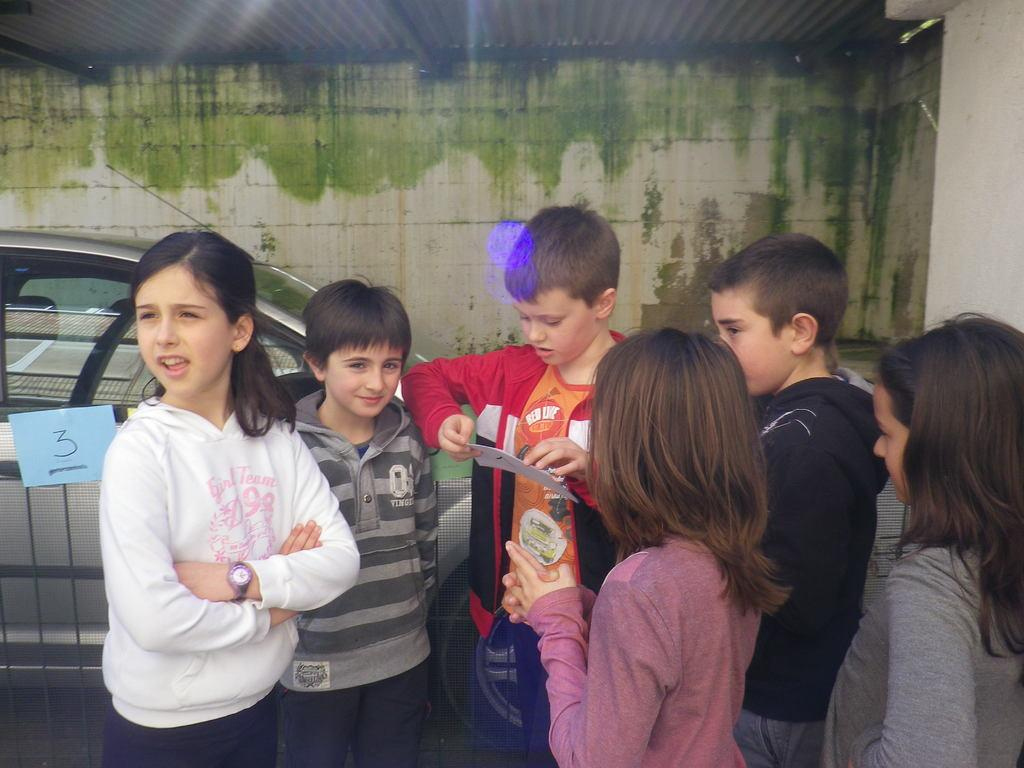What is the main subject of the image? The main subject of the image is a group of children. Where are the children located in the image? The children are standing on the ground. What else can be seen in the image besides the children? There is a car in the image. What is visible in the background of the image? There is a wall in the background of the image. What type of cattle can be seen grazing in the image? There is no cattle present in the image; it features a group of children standing on the ground, a car, and a wall in the background. 